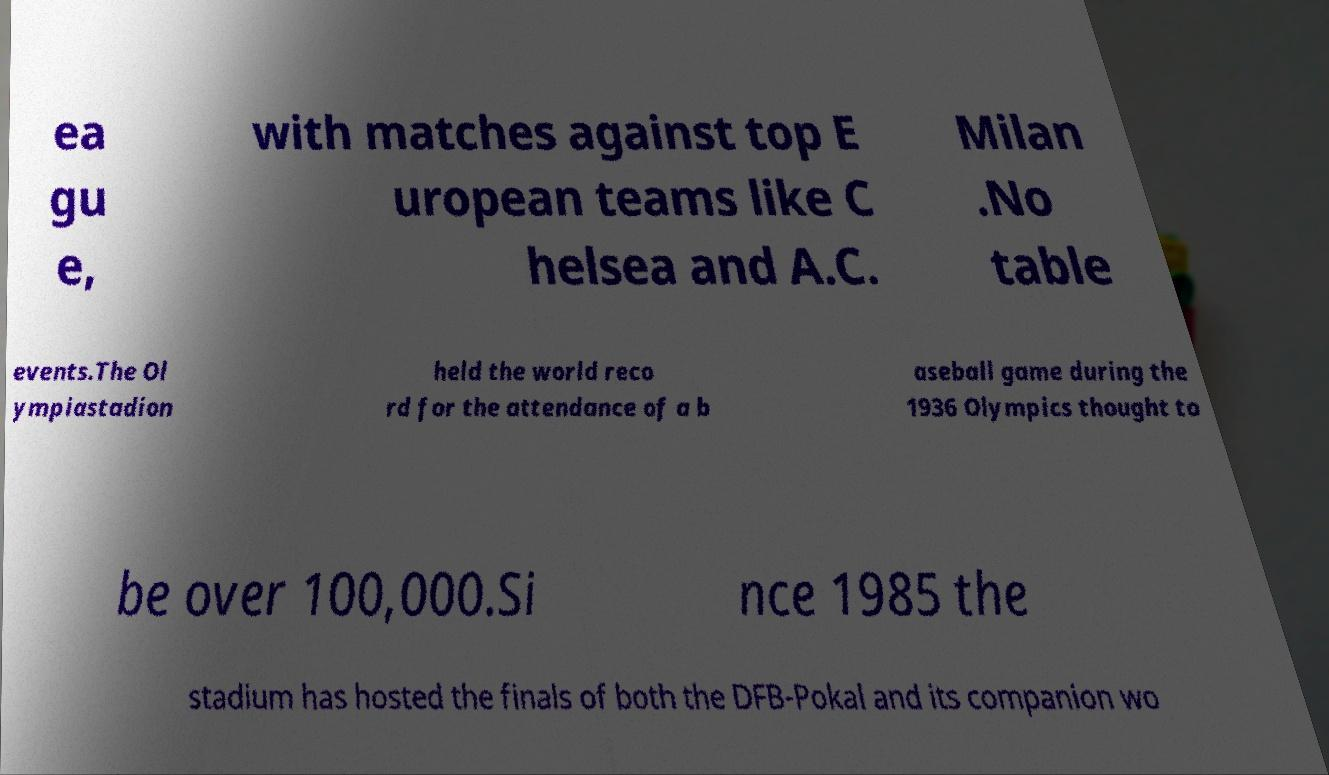Can you read and provide the text displayed in the image?This photo seems to have some interesting text. Can you extract and type it out for me? ea gu e, with matches against top E uropean teams like C helsea and A.C. Milan .No table events.The Ol ympiastadion held the world reco rd for the attendance of a b aseball game during the 1936 Olympics thought to be over 100,000.Si nce 1985 the stadium has hosted the finals of both the DFB-Pokal and its companion wo 